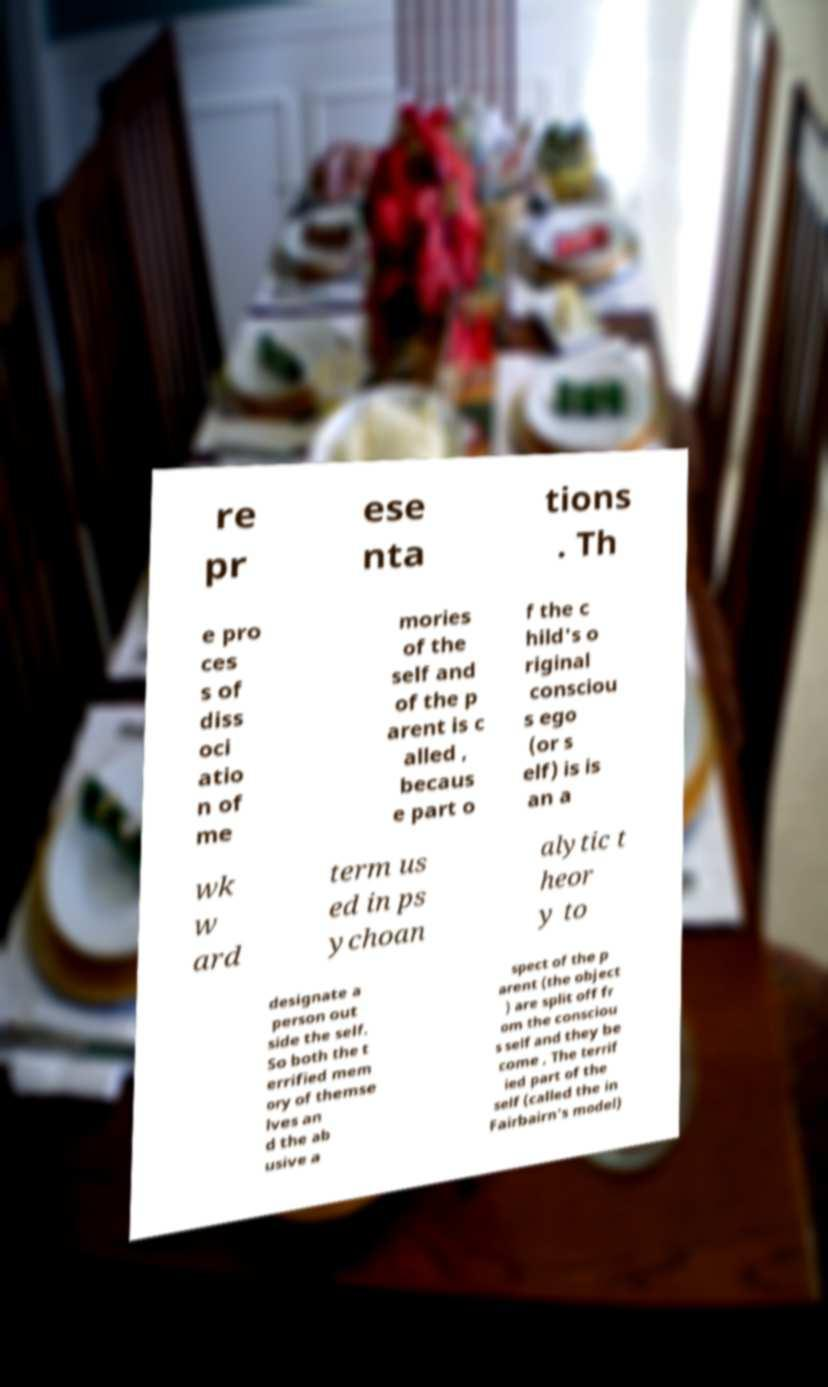For documentation purposes, I need the text within this image transcribed. Could you provide that? re pr ese nta tions . Th e pro ces s of diss oci atio n of me mories of the self and of the p arent is c alled , becaus e part o f the c hild's o riginal consciou s ego (or s elf) is is an a wk w ard term us ed in ps ychoan alytic t heor y to designate a person out side the self. So both the t errified mem ory of themse lves an d the ab usive a spect of the p arent (the object ) are split off fr om the consciou s self and they be come , The terrif ied part of the self (called the in Fairbairn's model) 